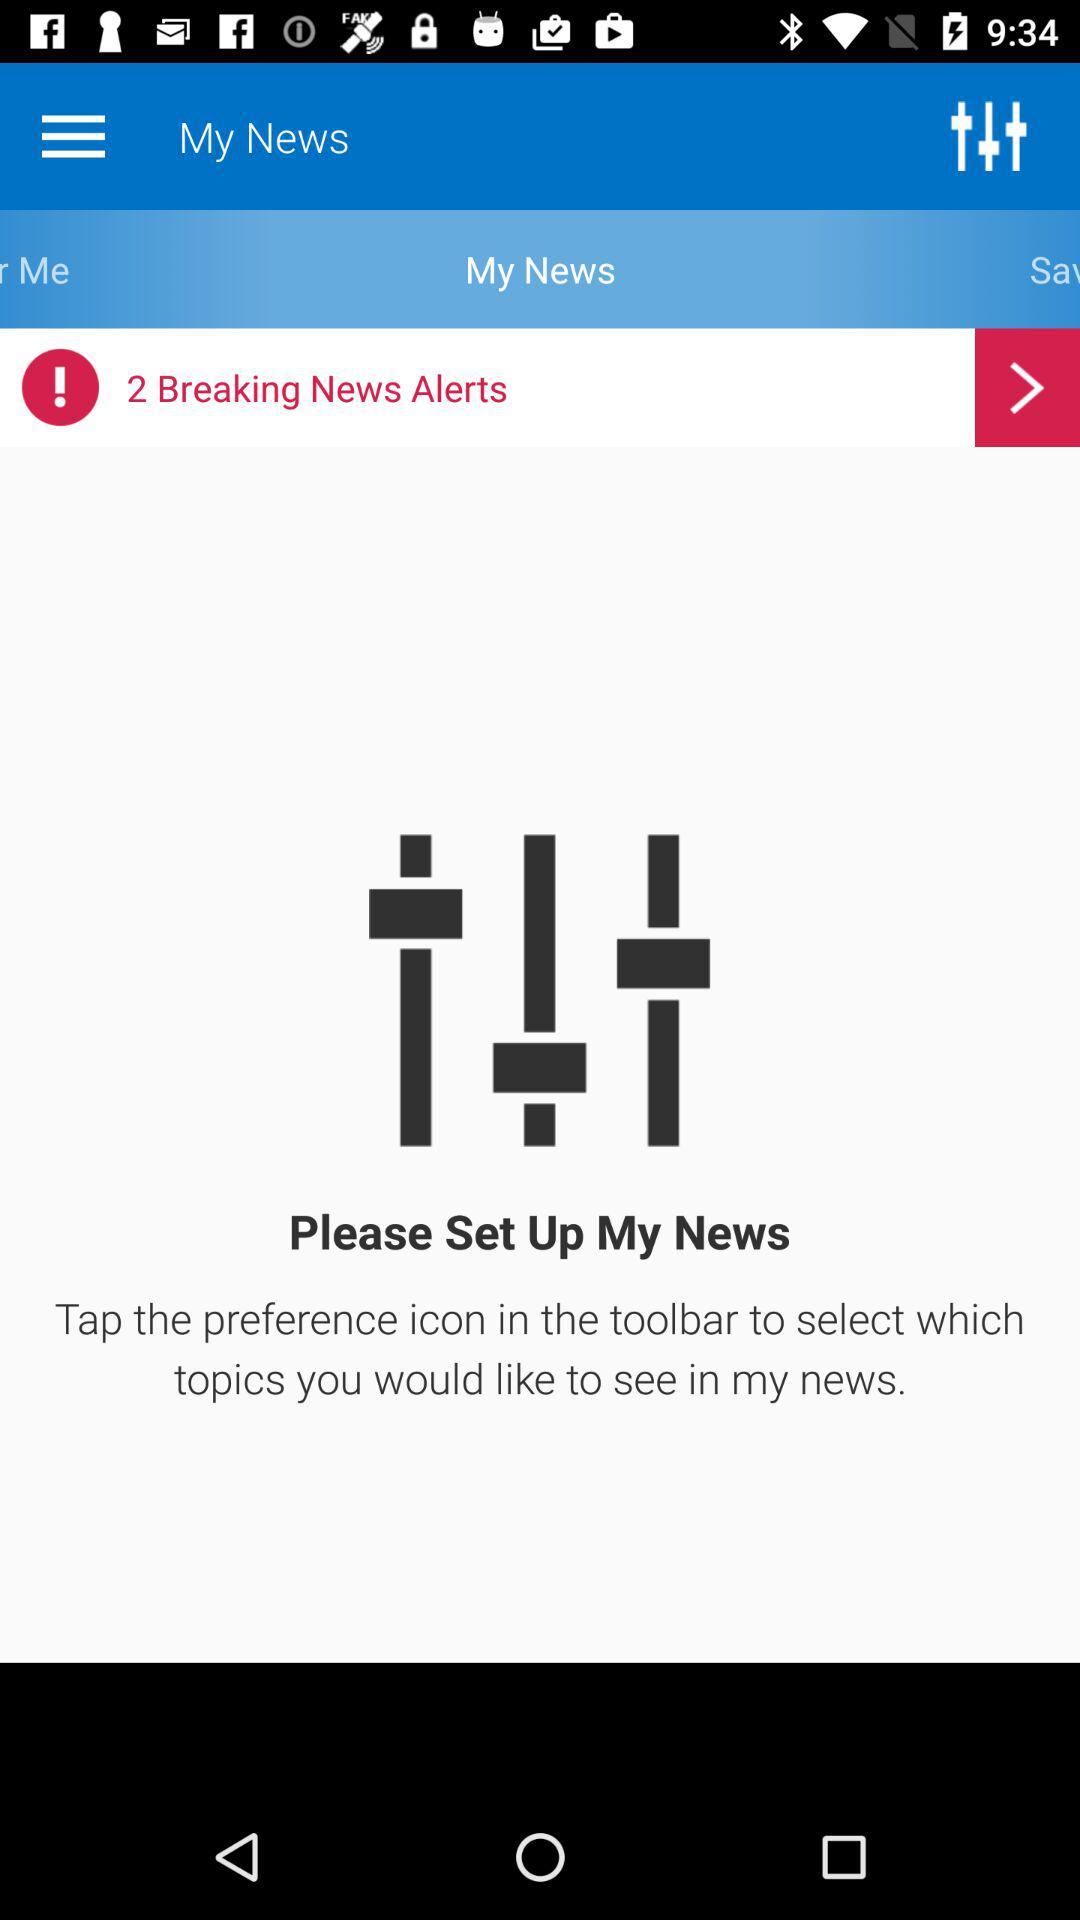How many breaking news alerts are there? There are 2 breaking news alerts. 